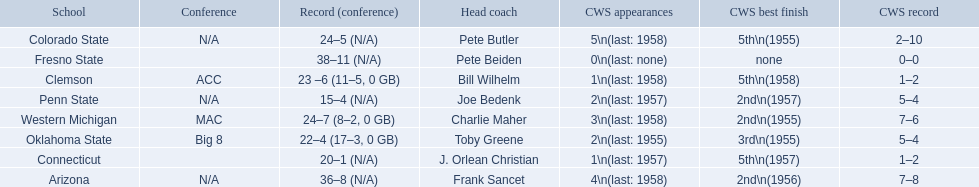What are all the schools? Arizona, Clemson, Colorado State, Connecticut, Fresno State, Oklahoma State, Penn State, Western Michigan. Which are clemson and western michigan? Clemson, Western Michigan. Of these, which has more cws appearances? Western Michigan. 